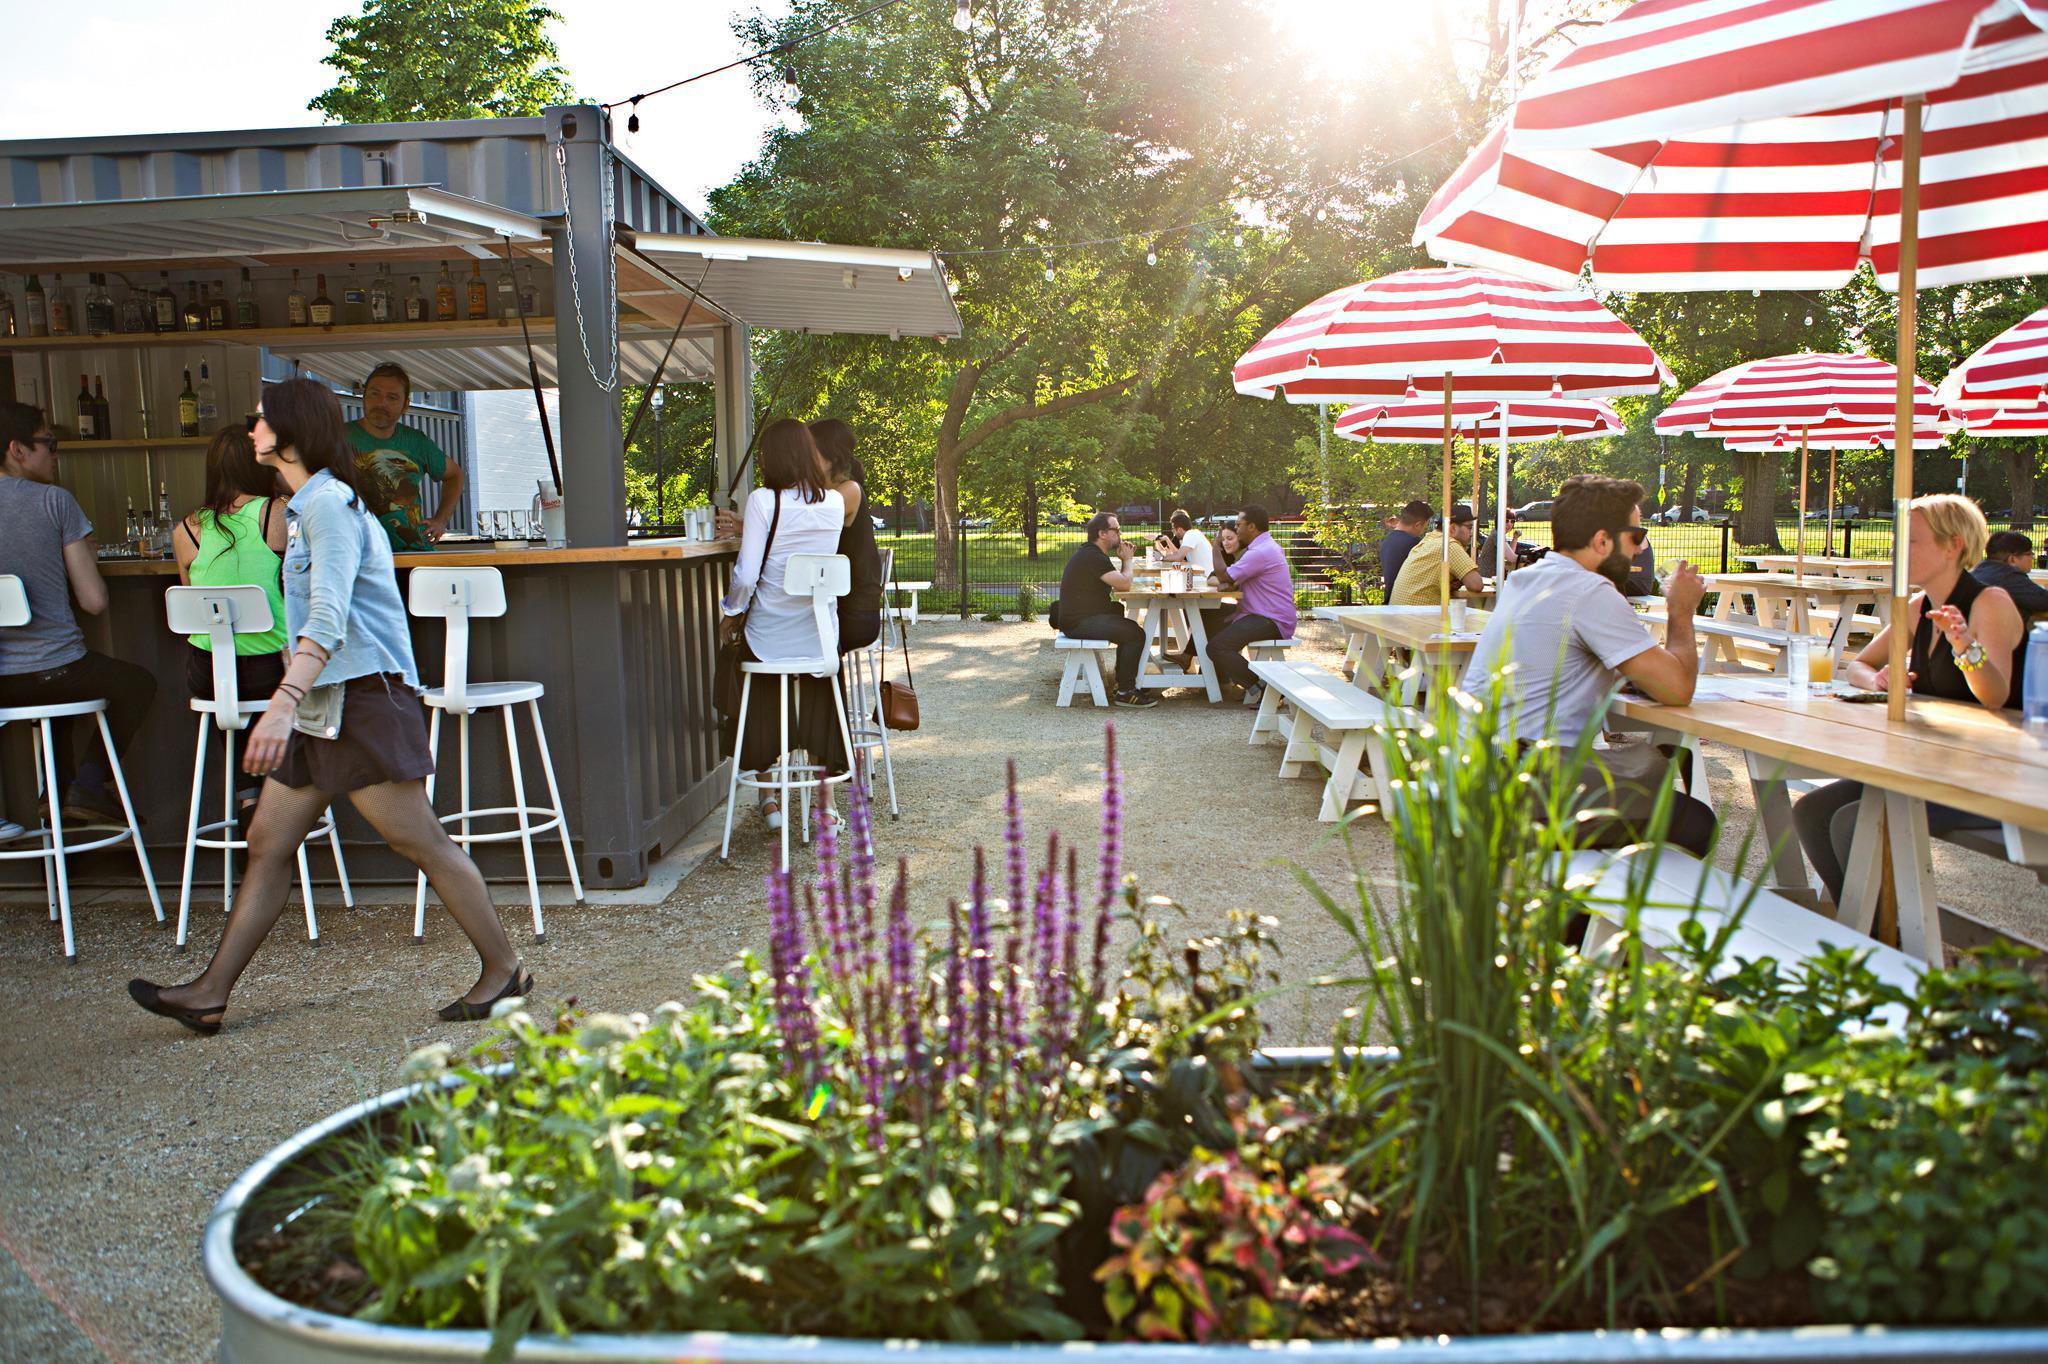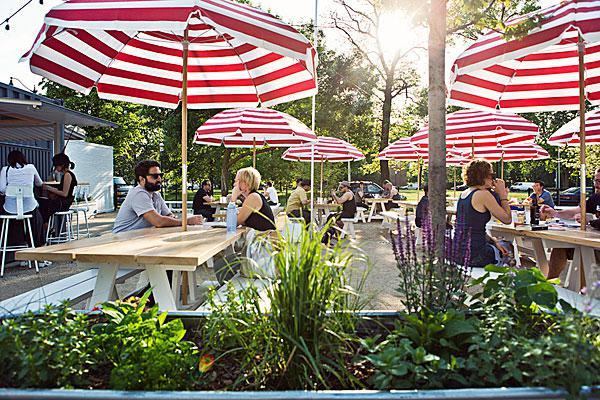The first image is the image on the left, the second image is the image on the right. For the images displayed, is the sentence "Umbrellas are set up over a dining area in the image on the right." factually correct? Answer yes or no. Yes. The first image is the image on the left, the second image is the image on the right. Assess this claim about the two images: "There area at least six tables covered in white linen with four chairs around them.". Correct or not? Answer yes or no. No. 